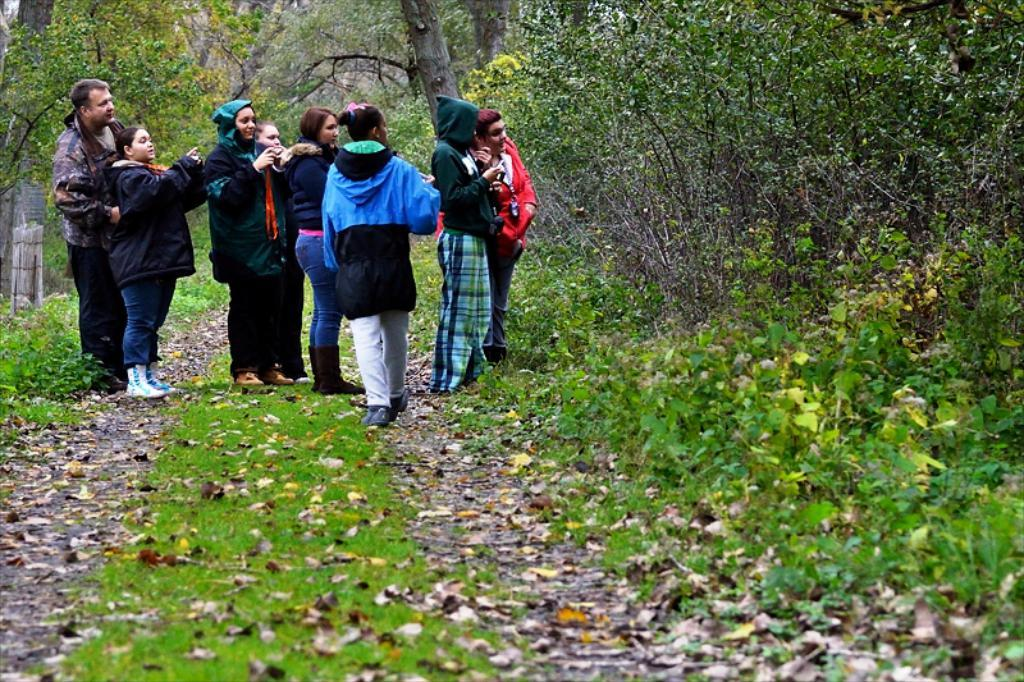What can be seen in the image involving human presence? There are people standing in the image. What type of vegetation is present in the image? Leaves, grass, plants, and trees are visible in the image. What color is the father's shirt in the image? There is no mention of a father or a shirt in the image, so we cannot answer this question. How does the light change throughout the image? The provided facts do not mention any changes in light, so we cannot answer this question. 